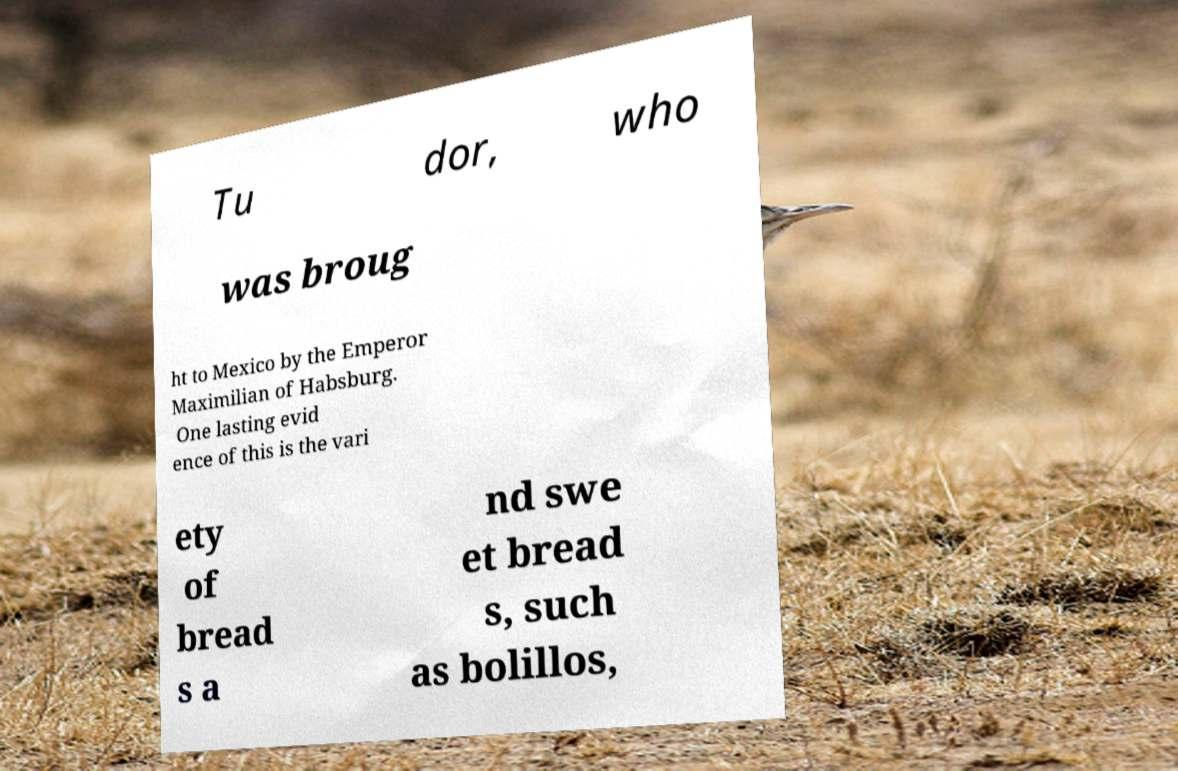For documentation purposes, I need the text within this image transcribed. Could you provide that? Tu dor, who was broug ht to Mexico by the Emperor Maximilian of Habsburg. One lasting evid ence of this is the vari ety of bread s a nd swe et bread s, such as bolillos, 